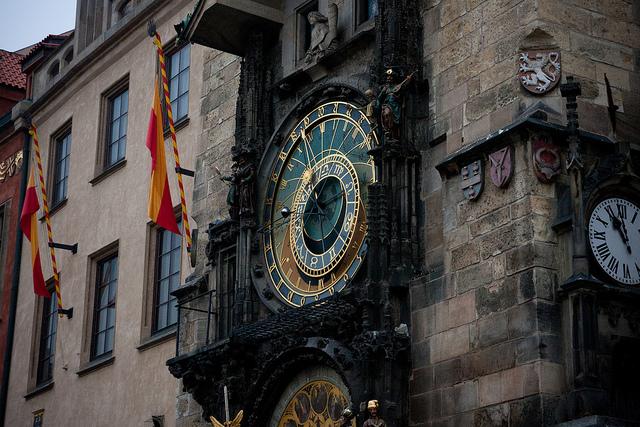What color is the clock?
Be succinct. Green and gold. What time is it?
Keep it brief. 2:30 pm. Are there crests on the building?
Answer briefly. Yes. How many flags?
Quick response, please. 2. 